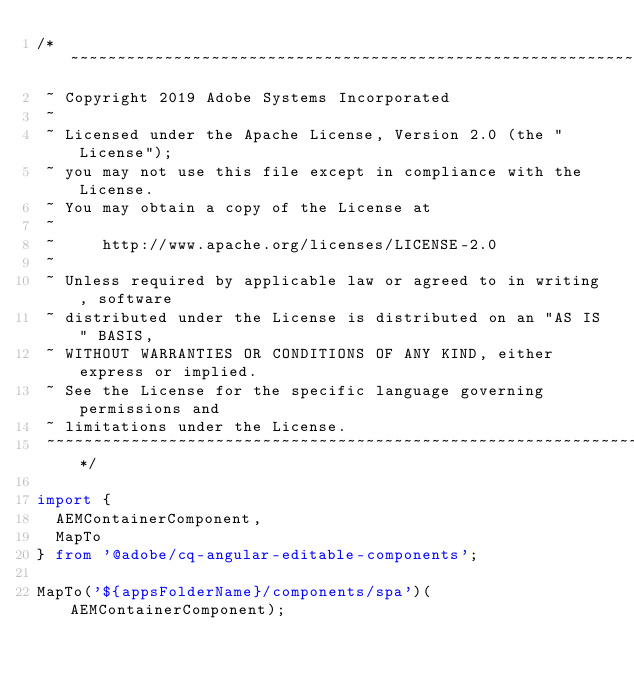Convert code to text. <code><loc_0><loc_0><loc_500><loc_500><_TypeScript_>/*~~~~~~~~~~~~~~~~~~~~~~~~~~~~~~~~~~~~~~~~~~~~~~~~~~~~~~~~~~~~~~~~~~~~~~~~~~~~~~
 ~ Copyright 2019 Adobe Systems Incorporated
 ~
 ~ Licensed under the Apache License, Version 2.0 (the "License");
 ~ you may not use this file except in compliance with the License.
 ~ You may obtain a copy of the License at
 ~
 ~     http://www.apache.org/licenses/LICENSE-2.0
 ~
 ~ Unless required by applicable law or agreed to in writing, software
 ~ distributed under the License is distributed on an "AS IS" BASIS,
 ~ WITHOUT WARRANTIES OR CONDITIONS OF ANY KIND, either express or implied.
 ~ See the License for the specific language governing permissions and
 ~ limitations under the License.
 ~~~~~~~~~~~~~~~~~~~~~~~~~~~~~~~~~~~~~~~~~~~~~~~~~~~~~~~~~~~~~~~~~~~~~~~~~~~~~*/

import {
  AEMContainerComponent,
  MapTo
} from '@adobe/cq-angular-editable-components';

MapTo('${appsFolderName}/components/spa')(AEMContainerComponent);
</code> 